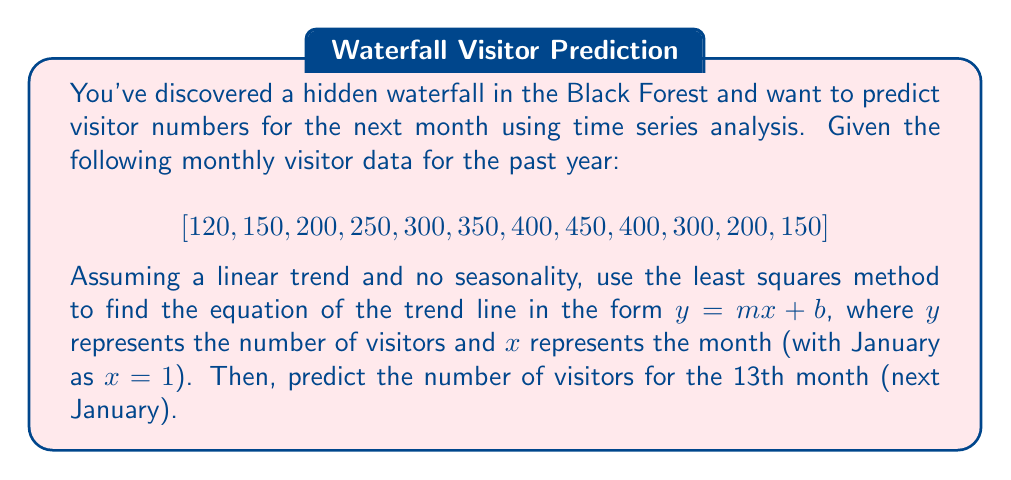Can you solve this math problem? 1) First, we need to set up our data points. Let $x$ be the month number and $y$ be the number of visitors:

   $$(x_i, y_i) = (1, 120), (2, 150), ..., (12, 150)$$

2) To find the linear trend line $y = mx + b$, we need to calculate $m$ and $b$ using the least squares method:

   $$m = \frac{n\sum{x_iy_i} - \sum{x_i}\sum{y_i}}{n\sum{x_i^2} - (\sum{x_i})^2}$$
   
   $$b = \frac{\sum{y_i} - m\sum{x_i}}{n}$$

3) Calculate the sums:
   
   $\sum{x_i} = 1 + 2 + ... + 12 = 78$
   $\sum{y_i} = 120 + 150 + ... + 150 = 3270$
   $\sum{x_iy_i} = 1(120) + 2(150) + ... + 12(150) = 24,640$
   $\sum{x_i^2} = 1^2 + 2^2 + ... + 12^2 = 650$
   $n = 12$

4) Substitute these values into the formulas:

   $$m = \frac{12(24,640) - 78(3270)}{12(650) - 78^2} = \frac{40,440}{1716} = 23.57$$

   $$b = \frac{3270 - 23.57(78)}{12} = 88.17$$

5) Therefore, the trend line equation is:

   $$y = 23.57x + 88.17$$

6) To predict the number of visitors for the 13th month, substitute $x = 13$:

   $$y = 23.57(13) + 88.17 = 394.58$$

Rounding to the nearest whole number, we predict 395 visitors for the 13th month.
Answer: 395 visitors 